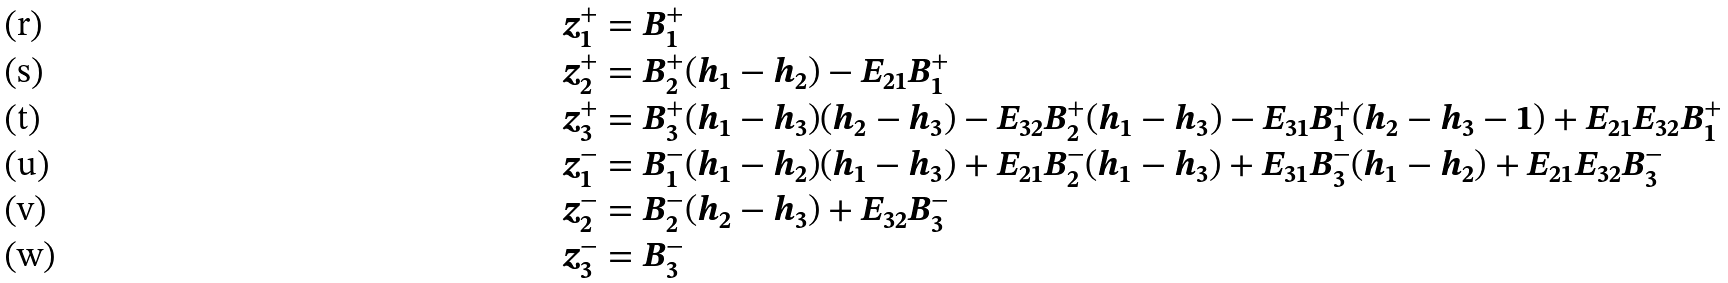Convert formula to latex. <formula><loc_0><loc_0><loc_500><loc_500>z _ { 1 } ^ { + } & = B _ { 1 } ^ { + } \\ z _ { 2 } ^ { + } & = B _ { 2 } ^ { + } ( h _ { 1 } - h _ { 2 } ) - E _ { 2 1 } B _ { 1 } ^ { + } \\ z _ { 3 } ^ { + } & = B _ { 3 } ^ { + } ( h _ { 1 } - h _ { 3 } ) ( h _ { 2 } - h _ { 3 } ) - E _ { 3 2 } B _ { 2 } ^ { + } ( h _ { 1 } - h _ { 3 } ) - E _ { 3 1 } B _ { 1 } ^ { + } ( h _ { 2 } - h _ { 3 } - 1 ) + E _ { 2 1 } E _ { 3 2 } B _ { 1 } ^ { + } \\ z _ { 1 } ^ { - } & = B _ { 1 } ^ { - } ( h _ { 1 } - h _ { 2 } ) ( h _ { 1 } - h _ { 3 } ) + E _ { 2 1 } B _ { 2 } ^ { - } ( h _ { 1 } - h _ { 3 } ) + E _ { 3 1 } B _ { 3 } ^ { - } ( h _ { 1 } - h _ { 2 } ) + E _ { 2 1 } E _ { 3 2 } B _ { 3 } ^ { - } \\ z _ { 2 } ^ { - } & = B _ { 2 } ^ { - } ( h _ { 2 } - h _ { 3 } ) + E _ { 3 2 } B _ { 3 } ^ { - } \\ z _ { 3 } ^ { - } & = B _ { 3 } ^ { - }</formula> 